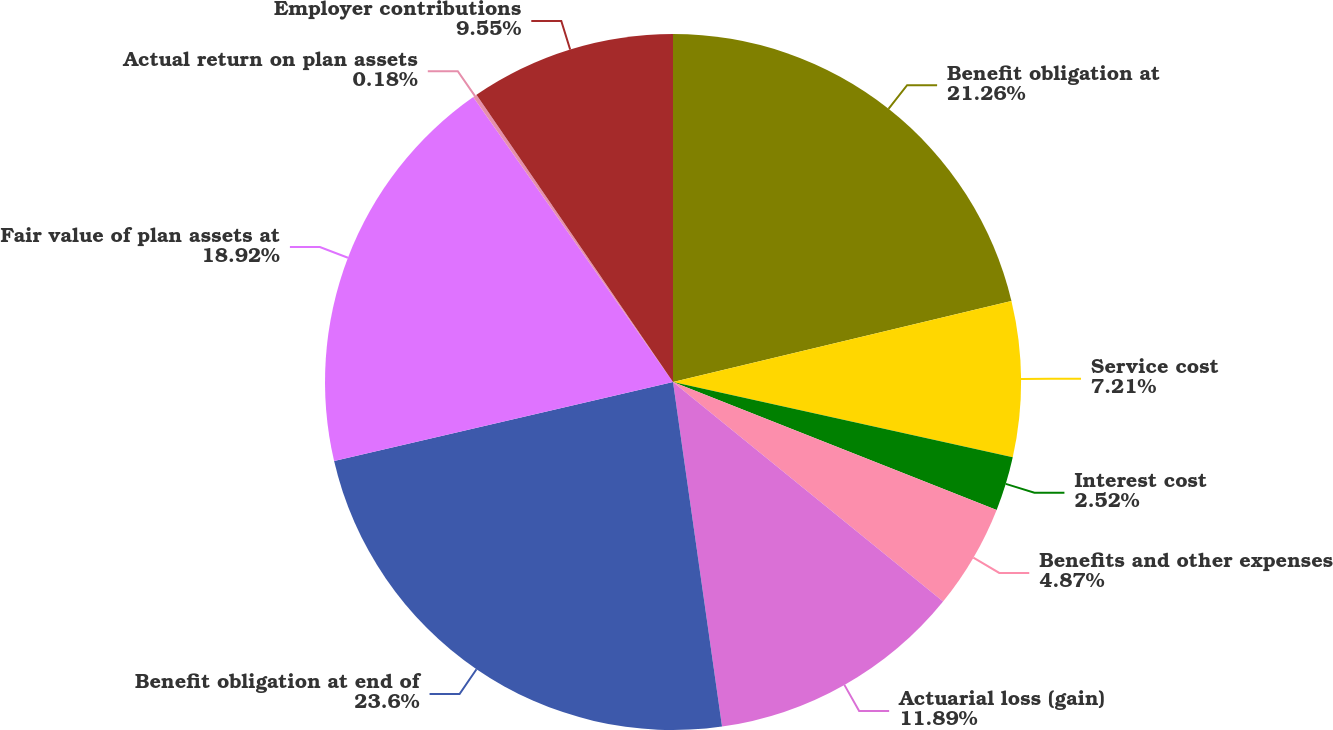Convert chart to OTSL. <chart><loc_0><loc_0><loc_500><loc_500><pie_chart><fcel>Benefit obligation at<fcel>Service cost<fcel>Interest cost<fcel>Benefits and other expenses<fcel>Actuarial loss (gain)<fcel>Benefit obligation at end of<fcel>Fair value of plan assets at<fcel>Actual return on plan assets<fcel>Employer contributions<nl><fcel>21.26%<fcel>7.21%<fcel>2.52%<fcel>4.87%<fcel>11.89%<fcel>23.6%<fcel>18.92%<fcel>0.18%<fcel>9.55%<nl></chart> 